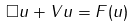Convert formula to latex. <formula><loc_0><loc_0><loc_500><loc_500>\Box u + V u = F ( u )</formula> 